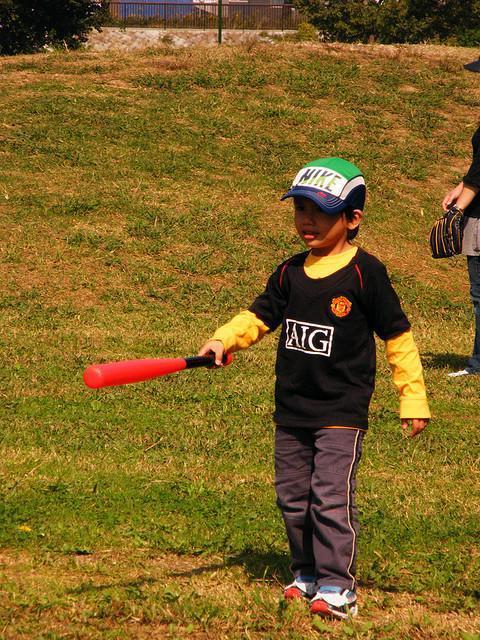How many people are there?
Give a very brief answer. 2. 